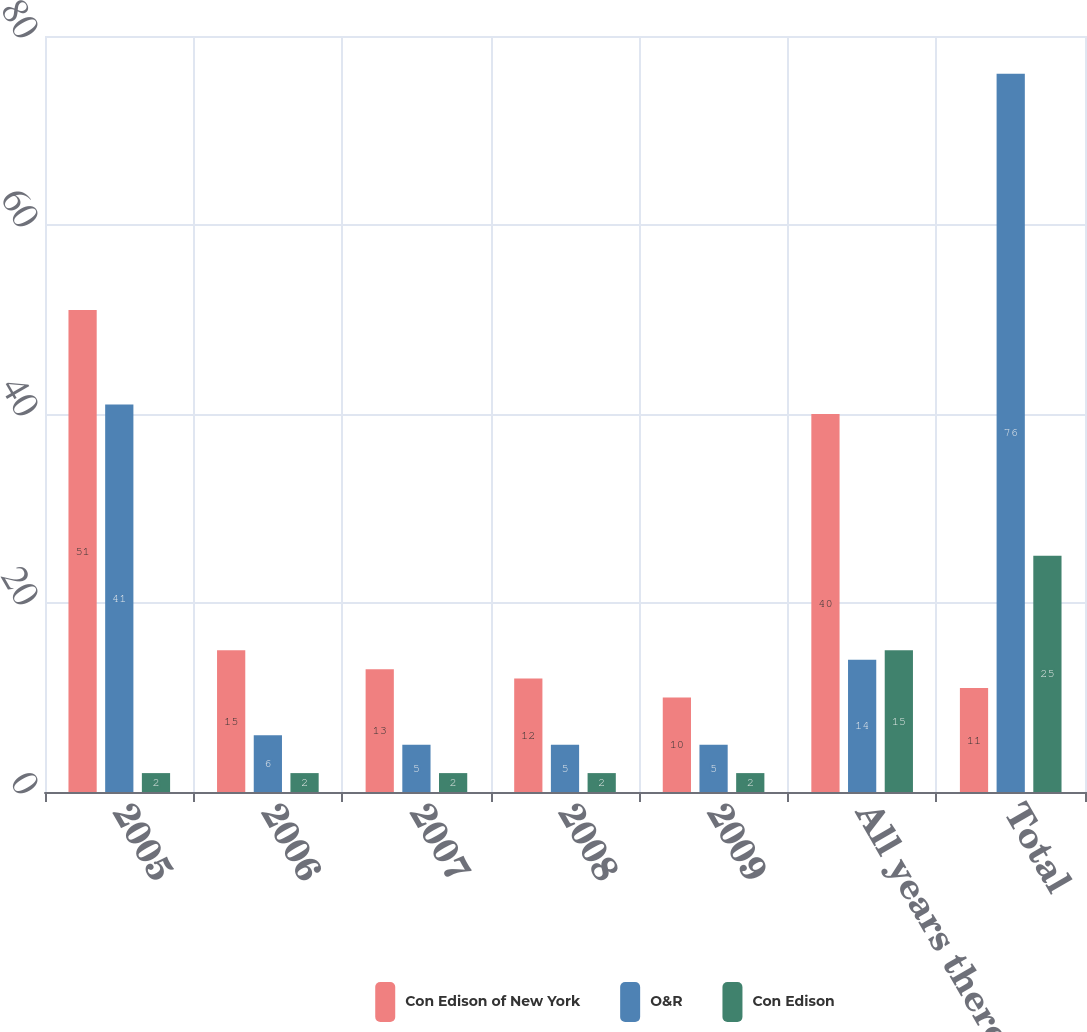<chart> <loc_0><loc_0><loc_500><loc_500><stacked_bar_chart><ecel><fcel>2005<fcel>2006<fcel>2007<fcel>2008<fcel>2009<fcel>All years thereafter<fcel>Total<nl><fcel>Con Edison of New York<fcel>51<fcel>15<fcel>13<fcel>12<fcel>10<fcel>40<fcel>11<nl><fcel>O&R<fcel>41<fcel>6<fcel>5<fcel>5<fcel>5<fcel>14<fcel>76<nl><fcel>Con Edison<fcel>2<fcel>2<fcel>2<fcel>2<fcel>2<fcel>15<fcel>25<nl></chart> 